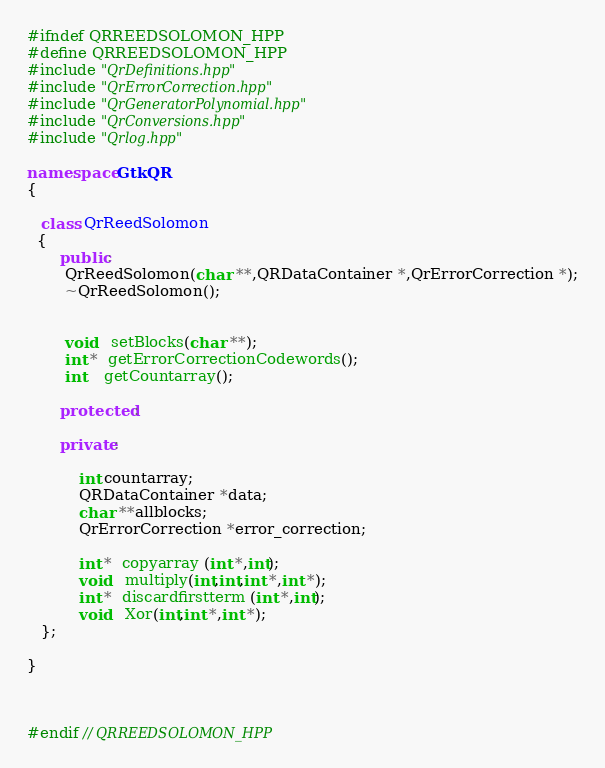Convert code to text. <code><loc_0><loc_0><loc_500><loc_500><_C++_>#ifndef QRREEDSOLOMON_HPP
#define QRREEDSOLOMON_HPP
#include "QrDefinitions.hpp"
#include "QrErrorCorrection.hpp"
#include "QrGeneratorPolynomial.hpp"
#include "QrConversions.hpp"
#include "Qrlog.hpp"

namespace GtkQR
{

   class QrReedSolomon
  {
       public:
        QrReedSolomon(char **,QRDataContainer *,QrErrorCorrection *);
        ~QrReedSolomon();


        void   setBlocks(char **);
        int *  getErrorCorrectionCodewords();
        int    getCountarray();

       protected:

       private:

           int countarray;
           QRDataContainer *data;
           char **allblocks;
           QrErrorCorrection *error_correction;

           int *  copyarray (int *,int);
           void   multiply(int,int,int *,int *);
           int *  discardfirstterm (int *,int);
           void   Xor(int,int *,int *);
   };

}



#endif // QRREEDSOLOMON_HPP
</code> 